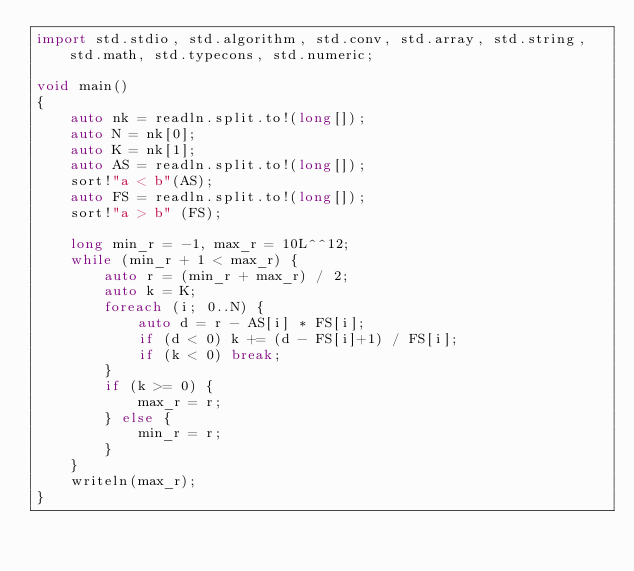Convert code to text. <code><loc_0><loc_0><loc_500><loc_500><_D_>import std.stdio, std.algorithm, std.conv, std.array, std.string, std.math, std.typecons, std.numeric;

void main()
{
    auto nk = readln.split.to!(long[]);
    auto N = nk[0];
    auto K = nk[1];
    auto AS = readln.split.to!(long[]);
    sort!"a < b"(AS);
    auto FS = readln.split.to!(long[]);
    sort!"a > b" (FS);

    long min_r = -1, max_r = 10L^^12;
    while (min_r + 1 < max_r) {
        auto r = (min_r + max_r) / 2;
        auto k = K;
        foreach (i; 0..N) {
            auto d = r - AS[i] * FS[i];
            if (d < 0) k += (d - FS[i]+1) / FS[i];
            if (k < 0) break;
        }
        if (k >= 0) {
            max_r = r;
        } else {
            min_r = r;
        }
    }
    writeln(max_r);
}</code> 